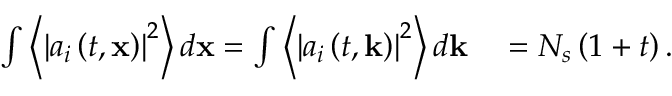<formula> <loc_0><loc_0><loc_500><loc_500>\begin{array} { r l } { \int \left \langle \left | a _ { i } \left ( t , x \right ) \right | ^ { 2 } \right \rangle d x = \int \left \langle \left | a _ { i } \left ( t , k \right ) \right | ^ { 2 } \right \rangle d k } & = N _ { s } \left ( 1 + t \right ) . } \end{array}</formula> 